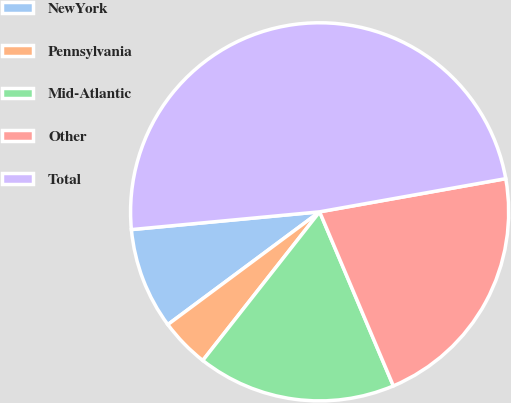Convert chart. <chart><loc_0><loc_0><loc_500><loc_500><pie_chart><fcel>NewYork<fcel>Pennsylvania<fcel>Mid-Atlantic<fcel>Other<fcel>Total<nl><fcel>8.67%<fcel>4.23%<fcel>16.98%<fcel>21.43%<fcel>48.69%<nl></chart> 